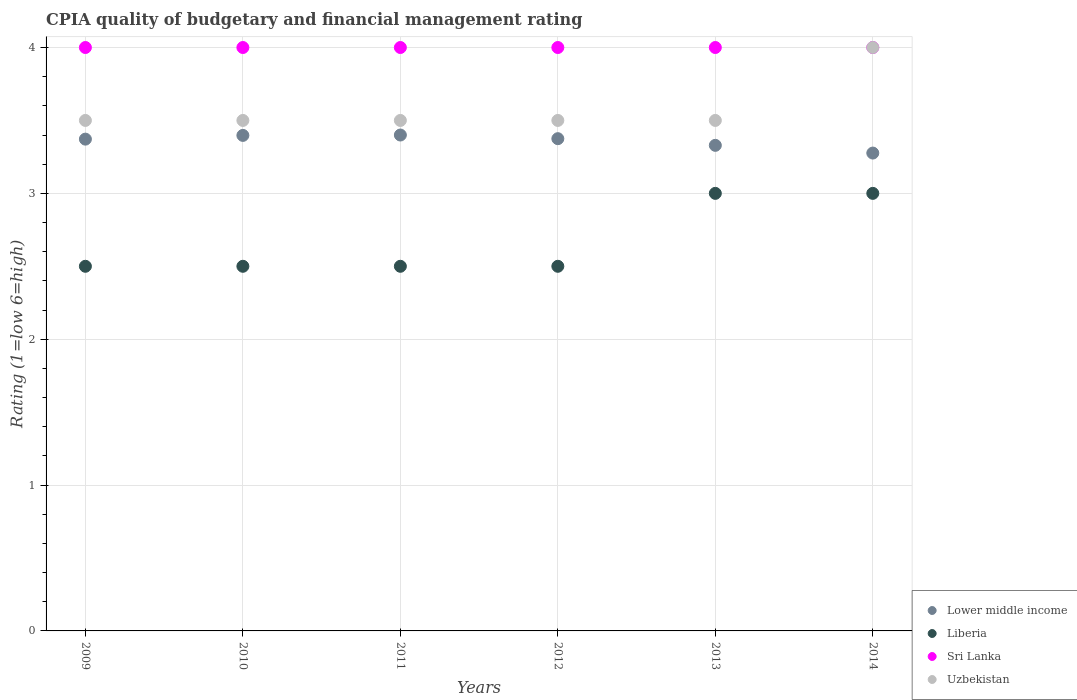Is the number of dotlines equal to the number of legend labels?
Your answer should be very brief. Yes. What is the CPIA rating in Lower middle income in 2012?
Offer a terse response. 3.38. Across all years, what is the maximum CPIA rating in Lower middle income?
Ensure brevity in your answer.  3.4. Across all years, what is the minimum CPIA rating in Lower middle income?
Offer a terse response. 3.28. In which year was the CPIA rating in Lower middle income maximum?
Offer a very short reply. 2011. What is the total CPIA rating in Uzbekistan in the graph?
Keep it short and to the point. 21.5. What is the average CPIA rating in Lower middle income per year?
Offer a very short reply. 3.36. In how many years, is the CPIA rating in Lower middle income greater than 0.2?
Provide a short and direct response. 6. What is the ratio of the CPIA rating in Sri Lanka in 2011 to that in 2014?
Your response must be concise. 1. What is the difference between the highest and the second highest CPIA rating in Uzbekistan?
Ensure brevity in your answer.  0.5. In how many years, is the CPIA rating in Uzbekistan greater than the average CPIA rating in Uzbekistan taken over all years?
Your response must be concise. 1. Is it the case that in every year, the sum of the CPIA rating in Uzbekistan and CPIA rating in Lower middle income  is greater than the CPIA rating in Liberia?
Your answer should be very brief. Yes. Does the CPIA rating in Liberia monotonically increase over the years?
Offer a very short reply. No. Are the values on the major ticks of Y-axis written in scientific E-notation?
Ensure brevity in your answer.  No. Does the graph contain grids?
Offer a very short reply. Yes. How many legend labels are there?
Offer a very short reply. 4. How are the legend labels stacked?
Your answer should be compact. Vertical. What is the title of the graph?
Keep it short and to the point. CPIA quality of budgetary and financial management rating. Does "St. Lucia" appear as one of the legend labels in the graph?
Provide a short and direct response. No. What is the label or title of the Y-axis?
Your response must be concise. Rating (1=low 6=high). What is the Rating (1=low 6=high) in Lower middle income in 2009?
Your answer should be compact. 3.37. What is the Rating (1=low 6=high) in Sri Lanka in 2009?
Ensure brevity in your answer.  4. What is the Rating (1=low 6=high) of Uzbekistan in 2009?
Ensure brevity in your answer.  3.5. What is the Rating (1=low 6=high) of Lower middle income in 2010?
Your response must be concise. 3.4. What is the Rating (1=low 6=high) in Liberia in 2010?
Give a very brief answer. 2.5. What is the Rating (1=low 6=high) in Sri Lanka in 2010?
Your response must be concise. 4. What is the Rating (1=low 6=high) of Uzbekistan in 2010?
Offer a very short reply. 3.5. What is the Rating (1=low 6=high) of Lower middle income in 2011?
Ensure brevity in your answer.  3.4. What is the Rating (1=low 6=high) in Liberia in 2011?
Make the answer very short. 2.5. What is the Rating (1=low 6=high) of Uzbekistan in 2011?
Your response must be concise. 3.5. What is the Rating (1=low 6=high) of Lower middle income in 2012?
Provide a short and direct response. 3.38. What is the Rating (1=low 6=high) in Liberia in 2012?
Provide a succinct answer. 2.5. What is the Rating (1=low 6=high) of Uzbekistan in 2012?
Offer a very short reply. 3.5. What is the Rating (1=low 6=high) of Lower middle income in 2013?
Provide a short and direct response. 3.33. What is the Rating (1=low 6=high) in Sri Lanka in 2013?
Offer a very short reply. 4. What is the Rating (1=low 6=high) of Uzbekistan in 2013?
Provide a succinct answer. 3.5. What is the Rating (1=low 6=high) in Lower middle income in 2014?
Your response must be concise. 3.28. Across all years, what is the maximum Rating (1=low 6=high) in Lower middle income?
Make the answer very short. 3.4. Across all years, what is the maximum Rating (1=low 6=high) of Liberia?
Ensure brevity in your answer.  3. Across all years, what is the maximum Rating (1=low 6=high) of Sri Lanka?
Keep it short and to the point. 4. Across all years, what is the maximum Rating (1=low 6=high) in Uzbekistan?
Give a very brief answer. 4. Across all years, what is the minimum Rating (1=low 6=high) in Lower middle income?
Give a very brief answer. 3.28. Across all years, what is the minimum Rating (1=low 6=high) of Liberia?
Make the answer very short. 2.5. Across all years, what is the minimum Rating (1=low 6=high) in Sri Lanka?
Your answer should be very brief. 4. Across all years, what is the minimum Rating (1=low 6=high) of Uzbekistan?
Provide a short and direct response. 3.5. What is the total Rating (1=low 6=high) of Lower middle income in the graph?
Ensure brevity in your answer.  20.15. What is the total Rating (1=low 6=high) of Sri Lanka in the graph?
Provide a succinct answer. 24. What is the difference between the Rating (1=low 6=high) of Lower middle income in 2009 and that in 2010?
Provide a short and direct response. -0.03. What is the difference between the Rating (1=low 6=high) in Liberia in 2009 and that in 2010?
Keep it short and to the point. 0. What is the difference between the Rating (1=low 6=high) in Sri Lanka in 2009 and that in 2010?
Your response must be concise. 0. What is the difference between the Rating (1=low 6=high) in Lower middle income in 2009 and that in 2011?
Offer a very short reply. -0.03. What is the difference between the Rating (1=low 6=high) of Liberia in 2009 and that in 2011?
Your answer should be very brief. 0. What is the difference between the Rating (1=low 6=high) of Sri Lanka in 2009 and that in 2011?
Provide a succinct answer. 0. What is the difference between the Rating (1=low 6=high) of Lower middle income in 2009 and that in 2012?
Keep it short and to the point. -0. What is the difference between the Rating (1=low 6=high) in Sri Lanka in 2009 and that in 2012?
Your answer should be compact. 0. What is the difference between the Rating (1=low 6=high) in Uzbekistan in 2009 and that in 2012?
Your response must be concise. 0. What is the difference between the Rating (1=low 6=high) in Lower middle income in 2009 and that in 2013?
Keep it short and to the point. 0.04. What is the difference between the Rating (1=low 6=high) in Liberia in 2009 and that in 2013?
Your answer should be very brief. -0.5. What is the difference between the Rating (1=low 6=high) in Uzbekistan in 2009 and that in 2013?
Your response must be concise. 0. What is the difference between the Rating (1=low 6=high) in Lower middle income in 2009 and that in 2014?
Make the answer very short. 0.1. What is the difference between the Rating (1=low 6=high) of Uzbekistan in 2009 and that in 2014?
Ensure brevity in your answer.  -0.5. What is the difference between the Rating (1=low 6=high) of Lower middle income in 2010 and that in 2011?
Provide a succinct answer. -0. What is the difference between the Rating (1=low 6=high) in Liberia in 2010 and that in 2011?
Provide a short and direct response. 0. What is the difference between the Rating (1=low 6=high) of Lower middle income in 2010 and that in 2012?
Provide a short and direct response. 0.02. What is the difference between the Rating (1=low 6=high) in Lower middle income in 2010 and that in 2013?
Provide a succinct answer. 0.07. What is the difference between the Rating (1=low 6=high) in Liberia in 2010 and that in 2013?
Offer a terse response. -0.5. What is the difference between the Rating (1=low 6=high) in Uzbekistan in 2010 and that in 2013?
Your answer should be compact. 0. What is the difference between the Rating (1=low 6=high) in Lower middle income in 2010 and that in 2014?
Provide a short and direct response. 0.12. What is the difference between the Rating (1=low 6=high) in Sri Lanka in 2010 and that in 2014?
Offer a terse response. 0. What is the difference between the Rating (1=low 6=high) in Uzbekistan in 2010 and that in 2014?
Keep it short and to the point. -0.5. What is the difference between the Rating (1=low 6=high) of Lower middle income in 2011 and that in 2012?
Offer a terse response. 0.03. What is the difference between the Rating (1=low 6=high) of Lower middle income in 2011 and that in 2013?
Provide a succinct answer. 0.07. What is the difference between the Rating (1=low 6=high) in Uzbekistan in 2011 and that in 2013?
Your response must be concise. 0. What is the difference between the Rating (1=low 6=high) in Lower middle income in 2011 and that in 2014?
Provide a short and direct response. 0.12. What is the difference between the Rating (1=low 6=high) in Liberia in 2011 and that in 2014?
Give a very brief answer. -0.5. What is the difference between the Rating (1=low 6=high) in Sri Lanka in 2011 and that in 2014?
Provide a succinct answer. 0. What is the difference between the Rating (1=low 6=high) of Lower middle income in 2012 and that in 2013?
Your answer should be very brief. 0.05. What is the difference between the Rating (1=low 6=high) of Sri Lanka in 2012 and that in 2013?
Provide a short and direct response. 0. What is the difference between the Rating (1=low 6=high) of Lower middle income in 2012 and that in 2014?
Your answer should be compact. 0.1. What is the difference between the Rating (1=low 6=high) in Sri Lanka in 2012 and that in 2014?
Provide a succinct answer. 0. What is the difference between the Rating (1=low 6=high) of Uzbekistan in 2012 and that in 2014?
Give a very brief answer. -0.5. What is the difference between the Rating (1=low 6=high) in Lower middle income in 2013 and that in 2014?
Keep it short and to the point. 0.05. What is the difference between the Rating (1=low 6=high) of Sri Lanka in 2013 and that in 2014?
Offer a terse response. 0. What is the difference between the Rating (1=low 6=high) in Uzbekistan in 2013 and that in 2014?
Your answer should be compact. -0.5. What is the difference between the Rating (1=low 6=high) in Lower middle income in 2009 and the Rating (1=low 6=high) in Liberia in 2010?
Give a very brief answer. 0.87. What is the difference between the Rating (1=low 6=high) in Lower middle income in 2009 and the Rating (1=low 6=high) in Sri Lanka in 2010?
Make the answer very short. -0.63. What is the difference between the Rating (1=low 6=high) in Lower middle income in 2009 and the Rating (1=low 6=high) in Uzbekistan in 2010?
Offer a very short reply. -0.13. What is the difference between the Rating (1=low 6=high) in Liberia in 2009 and the Rating (1=low 6=high) in Sri Lanka in 2010?
Give a very brief answer. -1.5. What is the difference between the Rating (1=low 6=high) in Lower middle income in 2009 and the Rating (1=low 6=high) in Liberia in 2011?
Make the answer very short. 0.87. What is the difference between the Rating (1=low 6=high) of Lower middle income in 2009 and the Rating (1=low 6=high) of Sri Lanka in 2011?
Your answer should be compact. -0.63. What is the difference between the Rating (1=low 6=high) in Lower middle income in 2009 and the Rating (1=low 6=high) in Uzbekistan in 2011?
Your answer should be very brief. -0.13. What is the difference between the Rating (1=low 6=high) in Liberia in 2009 and the Rating (1=low 6=high) in Uzbekistan in 2011?
Provide a succinct answer. -1. What is the difference between the Rating (1=low 6=high) in Sri Lanka in 2009 and the Rating (1=low 6=high) in Uzbekistan in 2011?
Make the answer very short. 0.5. What is the difference between the Rating (1=low 6=high) in Lower middle income in 2009 and the Rating (1=low 6=high) in Liberia in 2012?
Ensure brevity in your answer.  0.87. What is the difference between the Rating (1=low 6=high) of Lower middle income in 2009 and the Rating (1=low 6=high) of Sri Lanka in 2012?
Ensure brevity in your answer.  -0.63. What is the difference between the Rating (1=low 6=high) of Lower middle income in 2009 and the Rating (1=low 6=high) of Uzbekistan in 2012?
Your response must be concise. -0.13. What is the difference between the Rating (1=low 6=high) in Sri Lanka in 2009 and the Rating (1=low 6=high) in Uzbekistan in 2012?
Provide a succinct answer. 0.5. What is the difference between the Rating (1=low 6=high) in Lower middle income in 2009 and the Rating (1=low 6=high) in Liberia in 2013?
Your response must be concise. 0.37. What is the difference between the Rating (1=low 6=high) of Lower middle income in 2009 and the Rating (1=low 6=high) of Sri Lanka in 2013?
Offer a terse response. -0.63. What is the difference between the Rating (1=low 6=high) in Lower middle income in 2009 and the Rating (1=low 6=high) in Uzbekistan in 2013?
Offer a very short reply. -0.13. What is the difference between the Rating (1=low 6=high) of Liberia in 2009 and the Rating (1=low 6=high) of Sri Lanka in 2013?
Give a very brief answer. -1.5. What is the difference between the Rating (1=low 6=high) of Lower middle income in 2009 and the Rating (1=low 6=high) of Liberia in 2014?
Offer a terse response. 0.37. What is the difference between the Rating (1=low 6=high) of Lower middle income in 2009 and the Rating (1=low 6=high) of Sri Lanka in 2014?
Provide a succinct answer. -0.63. What is the difference between the Rating (1=low 6=high) of Lower middle income in 2009 and the Rating (1=low 6=high) of Uzbekistan in 2014?
Make the answer very short. -0.63. What is the difference between the Rating (1=low 6=high) of Liberia in 2009 and the Rating (1=low 6=high) of Uzbekistan in 2014?
Provide a succinct answer. -1.5. What is the difference between the Rating (1=low 6=high) of Sri Lanka in 2009 and the Rating (1=low 6=high) of Uzbekistan in 2014?
Make the answer very short. 0. What is the difference between the Rating (1=low 6=high) of Lower middle income in 2010 and the Rating (1=low 6=high) of Liberia in 2011?
Make the answer very short. 0.9. What is the difference between the Rating (1=low 6=high) of Lower middle income in 2010 and the Rating (1=low 6=high) of Sri Lanka in 2011?
Give a very brief answer. -0.6. What is the difference between the Rating (1=low 6=high) of Lower middle income in 2010 and the Rating (1=low 6=high) of Uzbekistan in 2011?
Provide a short and direct response. -0.1. What is the difference between the Rating (1=low 6=high) in Liberia in 2010 and the Rating (1=low 6=high) in Sri Lanka in 2011?
Ensure brevity in your answer.  -1.5. What is the difference between the Rating (1=low 6=high) in Lower middle income in 2010 and the Rating (1=low 6=high) in Liberia in 2012?
Provide a succinct answer. 0.9. What is the difference between the Rating (1=low 6=high) in Lower middle income in 2010 and the Rating (1=low 6=high) in Sri Lanka in 2012?
Your answer should be compact. -0.6. What is the difference between the Rating (1=low 6=high) of Lower middle income in 2010 and the Rating (1=low 6=high) of Uzbekistan in 2012?
Your answer should be compact. -0.1. What is the difference between the Rating (1=low 6=high) of Liberia in 2010 and the Rating (1=low 6=high) of Sri Lanka in 2012?
Your answer should be very brief. -1.5. What is the difference between the Rating (1=low 6=high) of Lower middle income in 2010 and the Rating (1=low 6=high) of Liberia in 2013?
Your answer should be very brief. 0.4. What is the difference between the Rating (1=low 6=high) in Lower middle income in 2010 and the Rating (1=low 6=high) in Sri Lanka in 2013?
Make the answer very short. -0.6. What is the difference between the Rating (1=low 6=high) in Lower middle income in 2010 and the Rating (1=low 6=high) in Uzbekistan in 2013?
Make the answer very short. -0.1. What is the difference between the Rating (1=low 6=high) of Liberia in 2010 and the Rating (1=low 6=high) of Sri Lanka in 2013?
Make the answer very short. -1.5. What is the difference between the Rating (1=low 6=high) of Liberia in 2010 and the Rating (1=low 6=high) of Uzbekistan in 2013?
Give a very brief answer. -1. What is the difference between the Rating (1=low 6=high) in Sri Lanka in 2010 and the Rating (1=low 6=high) in Uzbekistan in 2013?
Offer a terse response. 0.5. What is the difference between the Rating (1=low 6=high) of Lower middle income in 2010 and the Rating (1=low 6=high) of Liberia in 2014?
Make the answer very short. 0.4. What is the difference between the Rating (1=low 6=high) in Lower middle income in 2010 and the Rating (1=low 6=high) in Sri Lanka in 2014?
Provide a succinct answer. -0.6. What is the difference between the Rating (1=low 6=high) of Lower middle income in 2010 and the Rating (1=low 6=high) of Uzbekistan in 2014?
Provide a short and direct response. -0.6. What is the difference between the Rating (1=low 6=high) in Liberia in 2010 and the Rating (1=low 6=high) in Sri Lanka in 2014?
Offer a terse response. -1.5. What is the difference between the Rating (1=low 6=high) in Liberia in 2010 and the Rating (1=low 6=high) in Uzbekistan in 2014?
Provide a short and direct response. -1.5. What is the difference between the Rating (1=low 6=high) of Lower middle income in 2011 and the Rating (1=low 6=high) of Uzbekistan in 2012?
Provide a short and direct response. -0.1. What is the difference between the Rating (1=low 6=high) of Liberia in 2011 and the Rating (1=low 6=high) of Sri Lanka in 2012?
Make the answer very short. -1.5. What is the difference between the Rating (1=low 6=high) of Liberia in 2011 and the Rating (1=low 6=high) of Uzbekistan in 2012?
Give a very brief answer. -1. What is the difference between the Rating (1=low 6=high) in Sri Lanka in 2011 and the Rating (1=low 6=high) in Uzbekistan in 2012?
Give a very brief answer. 0.5. What is the difference between the Rating (1=low 6=high) in Lower middle income in 2011 and the Rating (1=low 6=high) in Uzbekistan in 2013?
Your answer should be very brief. -0.1. What is the difference between the Rating (1=low 6=high) in Liberia in 2011 and the Rating (1=low 6=high) in Sri Lanka in 2013?
Your answer should be compact. -1.5. What is the difference between the Rating (1=low 6=high) in Liberia in 2011 and the Rating (1=low 6=high) in Uzbekistan in 2013?
Provide a short and direct response. -1. What is the difference between the Rating (1=low 6=high) in Sri Lanka in 2011 and the Rating (1=low 6=high) in Uzbekistan in 2013?
Your response must be concise. 0.5. What is the difference between the Rating (1=low 6=high) of Lower middle income in 2011 and the Rating (1=low 6=high) of Liberia in 2014?
Keep it short and to the point. 0.4. What is the difference between the Rating (1=low 6=high) in Lower middle income in 2011 and the Rating (1=low 6=high) in Sri Lanka in 2014?
Provide a short and direct response. -0.6. What is the difference between the Rating (1=low 6=high) of Liberia in 2011 and the Rating (1=low 6=high) of Sri Lanka in 2014?
Offer a very short reply. -1.5. What is the difference between the Rating (1=low 6=high) in Lower middle income in 2012 and the Rating (1=low 6=high) in Liberia in 2013?
Make the answer very short. 0.38. What is the difference between the Rating (1=low 6=high) in Lower middle income in 2012 and the Rating (1=low 6=high) in Sri Lanka in 2013?
Your answer should be compact. -0.62. What is the difference between the Rating (1=low 6=high) in Lower middle income in 2012 and the Rating (1=low 6=high) in Uzbekistan in 2013?
Keep it short and to the point. -0.12. What is the difference between the Rating (1=low 6=high) of Lower middle income in 2012 and the Rating (1=low 6=high) of Sri Lanka in 2014?
Make the answer very short. -0.62. What is the difference between the Rating (1=low 6=high) in Lower middle income in 2012 and the Rating (1=low 6=high) in Uzbekistan in 2014?
Offer a terse response. -0.62. What is the difference between the Rating (1=low 6=high) in Sri Lanka in 2012 and the Rating (1=low 6=high) in Uzbekistan in 2014?
Give a very brief answer. 0. What is the difference between the Rating (1=low 6=high) of Lower middle income in 2013 and the Rating (1=low 6=high) of Liberia in 2014?
Your answer should be compact. 0.33. What is the difference between the Rating (1=low 6=high) of Lower middle income in 2013 and the Rating (1=low 6=high) of Sri Lanka in 2014?
Keep it short and to the point. -0.67. What is the difference between the Rating (1=low 6=high) in Lower middle income in 2013 and the Rating (1=low 6=high) in Uzbekistan in 2014?
Offer a terse response. -0.67. What is the difference between the Rating (1=low 6=high) in Liberia in 2013 and the Rating (1=low 6=high) in Sri Lanka in 2014?
Provide a short and direct response. -1. What is the difference between the Rating (1=low 6=high) of Liberia in 2013 and the Rating (1=low 6=high) of Uzbekistan in 2014?
Your answer should be compact. -1. What is the difference between the Rating (1=low 6=high) in Sri Lanka in 2013 and the Rating (1=low 6=high) in Uzbekistan in 2014?
Ensure brevity in your answer.  0. What is the average Rating (1=low 6=high) of Lower middle income per year?
Keep it short and to the point. 3.36. What is the average Rating (1=low 6=high) of Liberia per year?
Make the answer very short. 2.67. What is the average Rating (1=low 6=high) of Uzbekistan per year?
Provide a succinct answer. 3.58. In the year 2009, what is the difference between the Rating (1=low 6=high) of Lower middle income and Rating (1=low 6=high) of Liberia?
Your response must be concise. 0.87. In the year 2009, what is the difference between the Rating (1=low 6=high) in Lower middle income and Rating (1=low 6=high) in Sri Lanka?
Your answer should be very brief. -0.63. In the year 2009, what is the difference between the Rating (1=low 6=high) of Lower middle income and Rating (1=low 6=high) of Uzbekistan?
Keep it short and to the point. -0.13. In the year 2009, what is the difference between the Rating (1=low 6=high) of Sri Lanka and Rating (1=low 6=high) of Uzbekistan?
Your answer should be compact. 0.5. In the year 2010, what is the difference between the Rating (1=low 6=high) in Lower middle income and Rating (1=low 6=high) in Liberia?
Your answer should be compact. 0.9. In the year 2010, what is the difference between the Rating (1=low 6=high) of Lower middle income and Rating (1=low 6=high) of Sri Lanka?
Keep it short and to the point. -0.6. In the year 2010, what is the difference between the Rating (1=low 6=high) of Lower middle income and Rating (1=low 6=high) of Uzbekistan?
Your answer should be very brief. -0.1. In the year 2010, what is the difference between the Rating (1=low 6=high) of Liberia and Rating (1=low 6=high) of Sri Lanka?
Keep it short and to the point. -1.5. In the year 2011, what is the difference between the Rating (1=low 6=high) in Lower middle income and Rating (1=low 6=high) in Liberia?
Provide a short and direct response. 0.9. In the year 2011, what is the difference between the Rating (1=low 6=high) of Liberia and Rating (1=low 6=high) of Sri Lanka?
Your answer should be very brief. -1.5. In the year 2012, what is the difference between the Rating (1=low 6=high) in Lower middle income and Rating (1=low 6=high) in Liberia?
Keep it short and to the point. 0.88. In the year 2012, what is the difference between the Rating (1=low 6=high) of Lower middle income and Rating (1=low 6=high) of Sri Lanka?
Give a very brief answer. -0.62. In the year 2012, what is the difference between the Rating (1=low 6=high) in Lower middle income and Rating (1=low 6=high) in Uzbekistan?
Your answer should be very brief. -0.12. In the year 2012, what is the difference between the Rating (1=low 6=high) in Liberia and Rating (1=low 6=high) in Sri Lanka?
Provide a succinct answer. -1.5. In the year 2012, what is the difference between the Rating (1=low 6=high) in Liberia and Rating (1=low 6=high) in Uzbekistan?
Your answer should be compact. -1. In the year 2012, what is the difference between the Rating (1=low 6=high) of Sri Lanka and Rating (1=low 6=high) of Uzbekistan?
Offer a terse response. 0.5. In the year 2013, what is the difference between the Rating (1=low 6=high) in Lower middle income and Rating (1=low 6=high) in Liberia?
Offer a very short reply. 0.33. In the year 2013, what is the difference between the Rating (1=low 6=high) of Lower middle income and Rating (1=low 6=high) of Sri Lanka?
Your response must be concise. -0.67. In the year 2013, what is the difference between the Rating (1=low 6=high) in Lower middle income and Rating (1=low 6=high) in Uzbekistan?
Your answer should be very brief. -0.17. In the year 2013, what is the difference between the Rating (1=low 6=high) in Liberia and Rating (1=low 6=high) in Uzbekistan?
Keep it short and to the point. -0.5. In the year 2013, what is the difference between the Rating (1=low 6=high) in Sri Lanka and Rating (1=low 6=high) in Uzbekistan?
Offer a terse response. 0.5. In the year 2014, what is the difference between the Rating (1=low 6=high) of Lower middle income and Rating (1=low 6=high) of Liberia?
Your answer should be compact. 0.28. In the year 2014, what is the difference between the Rating (1=low 6=high) in Lower middle income and Rating (1=low 6=high) in Sri Lanka?
Make the answer very short. -0.72. In the year 2014, what is the difference between the Rating (1=low 6=high) in Lower middle income and Rating (1=low 6=high) in Uzbekistan?
Provide a short and direct response. -0.72. In the year 2014, what is the difference between the Rating (1=low 6=high) of Liberia and Rating (1=low 6=high) of Sri Lanka?
Your response must be concise. -1. What is the ratio of the Rating (1=low 6=high) of Lower middle income in 2009 to that in 2010?
Your response must be concise. 0.99. What is the ratio of the Rating (1=low 6=high) in Liberia in 2009 to that in 2010?
Offer a very short reply. 1. What is the ratio of the Rating (1=low 6=high) in Sri Lanka in 2009 to that in 2010?
Your answer should be very brief. 1. What is the ratio of the Rating (1=low 6=high) of Lower middle income in 2009 to that in 2011?
Offer a terse response. 0.99. What is the ratio of the Rating (1=low 6=high) of Liberia in 2009 to that in 2011?
Offer a terse response. 1. What is the ratio of the Rating (1=low 6=high) in Uzbekistan in 2009 to that in 2011?
Your response must be concise. 1. What is the ratio of the Rating (1=low 6=high) in Liberia in 2009 to that in 2012?
Keep it short and to the point. 1. What is the ratio of the Rating (1=low 6=high) in Uzbekistan in 2009 to that in 2012?
Your answer should be very brief. 1. What is the ratio of the Rating (1=low 6=high) of Lower middle income in 2009 to that in 2013?
Your response must be concise. 1.01. What is the ratio of the Rating (1=low 6=high) of Sri Lanka in 2009 to that in 2013?
Make the answer very short. 1. What is the ratio of the Rating (1=low 6=high) of Uzbekistan in 2009 to that in 2013?
Offer a terse response. 1. What is the ratio of the Rating (1=low 6=high) of Lower middle income in 2009 to that in 2014?
Give a very brief answer. 1.03. What is the ratio of the Rating (1=low 6=high) in Liberia in 2009 to that in 2014?
Offer a terse response. 0.83. What is the ratio of the Rating (1=low 6=high) of Sri Lanka in 2009 to that in 2014?
Offer a terse response. 1. What is the ratio of the Rating (1=low 6=high) in Uzbekistan in 2009 to that in 2014?
Your answer should be very brief. 0.88. What is the ratio of the Rating (1=low 6=high) of Sri Lanka in 2010 to that in 2011?
Your answer should be compact. 1. What is the ratio of the Rating (1=low 6=high) in Uzbekistan in 2010 to that in 2011?
Offer a very short reply. 1. What is the ratio of the Rating (1=low 6=high) in Lower middle income in 2010 to that in 2012?
Your answer should be compact. 1.01. What is the ratio of the Rating (1=low 6=high) of Uzbekistan in 2010 to that in 2012?
Make the answer very short. 1. What is the ratio of the Rating (1=low 6=high) of Lower middle income in 2010 to that in 2013?
Keep it short and to the point. 1.02. What is the ratio of the Rating (1=low 6=high) in Sri Lanka in 2010 to that in 2013?
Provide a short and direct response. 1. What is the ratio of the Rating (1=low 6=high) of Uzbekistan in 2010 to that in 2013?
Give a very brief answer. 1. What is the ratio of the Rating (1=low 6=high) of Lower middle income in 2010 to that in 2014?
Give a very brief answer. 1.04. What is the ratio of the Rating (1=low 6=high) of Sri Lanka in 2010 to that in 2014?
Your response must be concise. 1. What is the ratio of the Rating (1=low 6=high) of Uzbekistan in 2010 to that in 2014?
Make the answer very short. 0.88. What is the ratio of the Rating (1=low 6=high) of Lower middle income in 2011 to that in 2012?
Your answer should be very brief. 1.01. What is the ratio of the Rating (1=low 6=high) of Lower middle income in 2011 to that in 2013?
Ensure brevity in your answer.  1.02. What is the ratio of the Rating (1=low 6=high) in Lower middle income in 2011 to that in 2014?
Your response must be concise. 1.04. What is the ratio of the Rating (1=low 6=high) of Liberia in 2011 to that in 2014?
Offer a terse response. 0.83. What is the ratio of the Rating (1=low 6=high) in Uzbekistan in 2011 to that in 2014?
Make the answer very short. 0.88. What is the ratio of the Rating (1=low 6=high) in Lower middle income in 2012 to that in 2013?
Ensure brevity in your answer.  1.01. What is the ratio of the Rating (1=low 6=high) of Sri Lanka in 2012 to that in 2013?
Give a very brief answer. 1. What is the ratio of the Rating (1=low 6=high) in Lower middle income in 2012 to that in 2014?
Provide a succinct answer. 1.03. What is the ratio of the Rating (1=low 6=high) of Lower middle income in 2013 to that in 2014?
Your answer should be very brief. 1.02. What is the ratio of the Rating (1=low 6=high) of Liberia in 2013 to that in 2014?
Your answer should be compact. 1. What is the difference between the highest and the second highest Rating (1=low 6=high) of Lower middle income?
Offer a terse response. 0. What is the difference between the highest and the lowest Rating (1=low 6=high) in Lower middle income?
Offer a terse response. 0.12. What is the difference between the highest and the lowest Rating (1=low 6=high) of Sri Lanka?
Your response must be concise. 0. What is the difference between the highest and the lowest Rating (1=low 6=high) of Uzbekistan?
Provide a short and direct response. 0.5. 